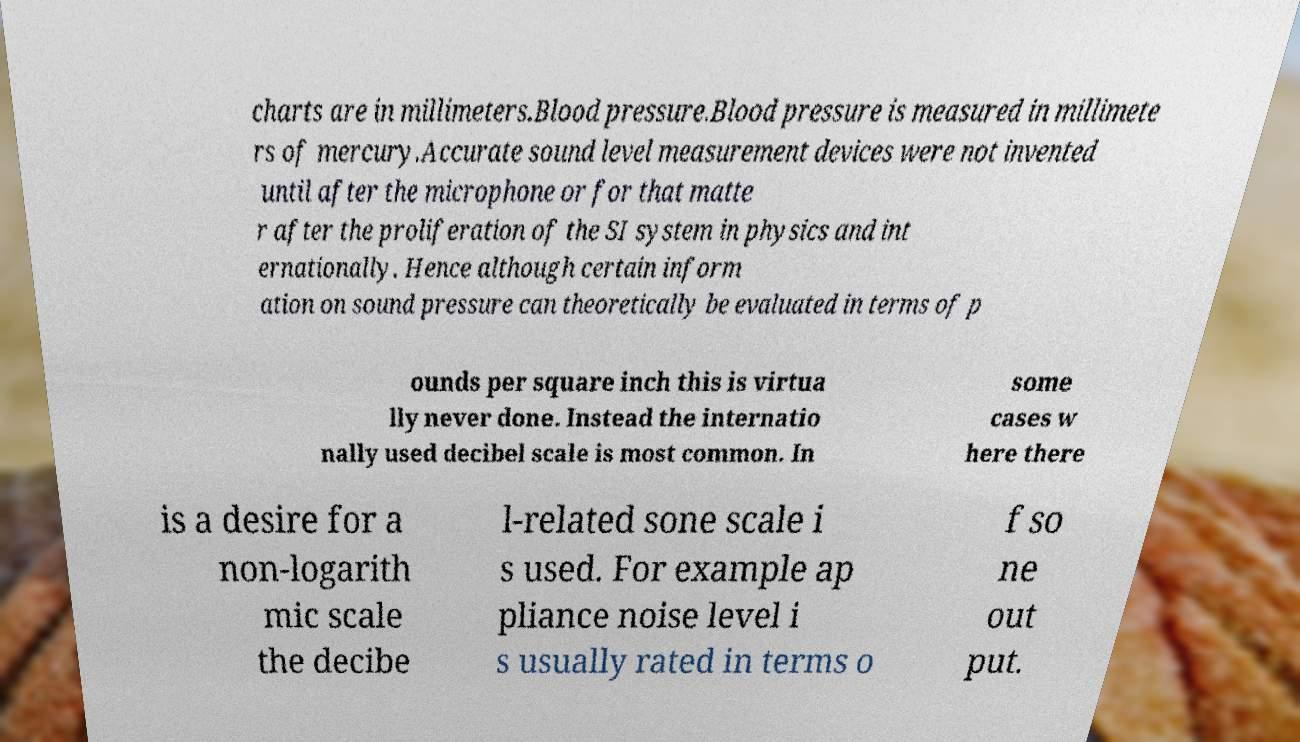There's text embedded in this image that I need extracted. Can you transcribe it verbatim? charts are in millimeters.Blood pressure.Blood pressure is measured in millimete rs of mercury.Accurate sound level measurement devices were not invented until after the microphone or for that matte r after the proliferation of the SI system in physics and int ernationally. Hence although certain inform ation on sound pressure can theoretically be evaluated in terms of p ounds per square inch this is virtua lly never done. Instead the internatio nally used decibel scale is most common. In some cases w here there is a desire for a non-logarith mic scale the decibe l-related sone scale i s used. For example ap pliance noise level i s usually rated in terms o f so ne out put. 